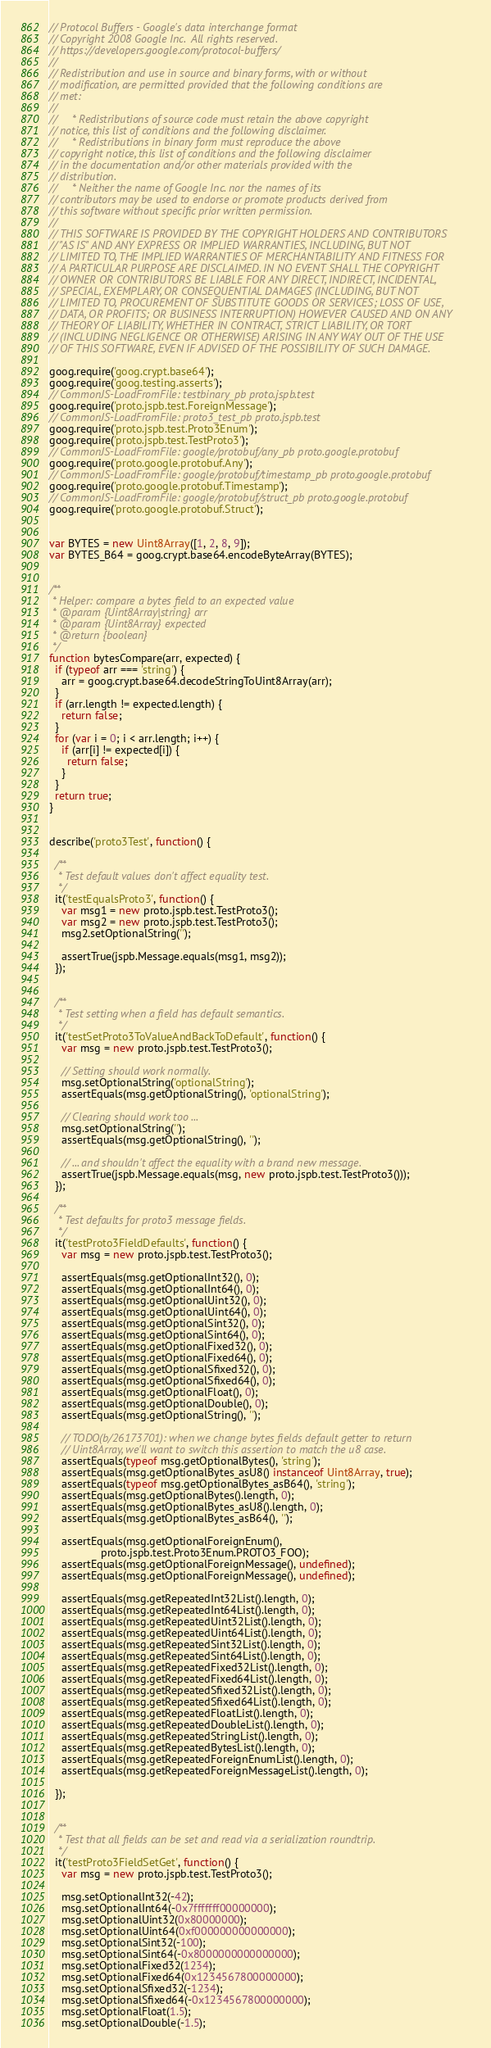Convert code to text. <code><loc_0><loc_0><loc_500><loc_500><_JavaScript_>// Protocol Buffers - Google's data interchange format
// Copyright 2008 Google Inc.  All rights reserved.
// https://developers.google.com/protocol-buffers/
//
// Redistribution and use in source and binary forms, with or without
// modification, are permitted provided that the following conditions are
// met:
//
//     * Redistributions of source code must retain the above copyright
// notice, this list of conditions and the following disclaimer.
//     * Redistributions in binary form must reproduce the above
// copyright notice, this list of conditions and the following disclaimer
// in the documentation and/or other materials provided with the
// distribution.
//     * Neither the name of Google Inc. nor the names of its
// contributors may be used to endorse or promote products derived from
// this software without specific prior written permission.
//
// THIS SOFTWARE IS PROVIDED BY THE COPYRIGHT HOLDERS AND CONTRIBUTORS
// "AS IS" AND ANY EXPRESS OR IMPLIED WARRANTIES, INCLUDING, BUT NOT
// LIMITED TO, THE IMPLIED WARRANTIES OF MERCHANTABILITY AND FITNESS FOR
// A PARTICULAR PURPOSE ARE DISCLAIMED. IN NO EVENT SHALL THE COPYRIGHT
// OWNER OR CONTRIBUTORS BE LIABLE FOR ANY DIRECT, INDIRECT, INCIDENTAL,
// SPECIAL, EXEMPLARY, OR CONSEQUENTIAL DAMAGES (INCLUDING, BUT NOT
// LIMITED TO, PROCUREMENT OF SUBSTITUTE GOODS OR SERVICES; LOSS OF USE,
// DATA, OR PROFITS; OR BUSINESS INTERRUPTION) HOWEVER CAUSED AND ON ANY
// THEORY OF LIABILITY, WHETHER IN CONTRACT, STRICT LIABILITY, OR TORT
// (INCLUDING NEGLIGENCE OR OTHERWISE) ARISING IN ANY WAY OUT OF THE USE
// OF THIS SOFTWARE, EVEN IF ADVISED OF THE POSSIBILITY OF SUCH DAMAGE.

goog.require('goog.crypt.base64');
goog.require('goog.testing.asserts');
// CommonJS-LoadFromFile: testbinary_pb proto.jspb.test
goog.require('proto.jspb.test.ForeignMessage');
// CommonJS-LoadFromFile: proto3_test_pb proto.jspb.test
goog.require('proto.jspb.test.Proto3Enum');
goog.require('proto.jspb.test.TestProto3');
// CommonJS-LoadFromFile: google/protobuf/any_pb proto.google.protobuf
goog.require('proto.google.protobuf.Any');
// CommonJS-LoadFromFile: google/protobuf/timestamp_pb proto.google.protobuf
goog.require('proto.google.protobuf.Timestamp');
// CommonJS-LoadFromFile: google/protobuf/struct_pb proto.google.protobuf
goog.require('proto.google.protobuf.Struct');


var BYTES = new Uint8Array([1, 2, 8, 9]);
var BYTES_B64 = goog.crypt.base64.encodeByteArray(BYTES);


/**
 * Helper: compare a bytes field to an expected value
 * @param {Uint8Array|string} arr
 * @param {Uint8Array} expected
 * @return {boolean}
 */
function bytesCompare(arr, expected) {
  if (typeof arr === 'string') {
    arr = goog.crypt.base64.decodeStringToUint8Array(arr);
  }
  if (arr.length != expected.length) {
    return false;
  }
  for (var i = 0; i < arr.length; i++) {
    if (arr[i] != expected[i]) {
      return false;
    }
  }
  return true;
}


describe('proto3Test', function() {

  /**
   * Test default values don't affect equality test.
   */
  it('testEqualsProto3', function() {
    var msg1 = new proto.jspb.test.TestProto3();
    var msg2 = new proto.jspb.test.TestProto3();
    msg2.setOptionalString('');

    assertTrue(jspb.Message.equals(msg1, msg2));
  });


  /**
   * Test setting when a field has default semantics.
   */
  it('testSetProto3ToValueAndBackToDefault', function() {
    var msg = new proto.jspb.test.TestProto3();

    // Setting should work normally.
    msg.setOptionalString('optionalString');
    assertEquals(msg.getOptionalString(), 'optionalString');

    // Clearing should work too ...
    msg.setOptionalString('');
    assertEquals(msg.getOptionalString(), '');

    // ... and shouldn't affect the equality with a brand new message.
    assertTrue(jspb.Message.equals(msg, new proto.jspb.test.TestProto3()));
  });

  /**
   * Test defaults for proto3 message fields.
   */
  it('testProto3FieldDefaults', function() {
    var msg = new proto.jspb.test.TestProto3();

    assertEquals(msg.getOptionalInt32(), 0);
    assertEquals(msg.getOptionalInt64(), 0);
    assertEquals(msg.getOptionalUint32(), 0);
    assertEquals(msg.getOptionalUint64(), 0);
    assertEquals(msg.getOptionalSint32(), 0);
    assertEquals(msg.getOptionalSint64(), 0);
    assertEquals(msg.getOptionalFixed32(), 0);
    assertEquals(msg.getOptionalFixed64(), 0);
    assertEquals(msg.getOptionalSfixed32(), 0);
    assertEquals(msg.getOptionalSfixed64(), 0);
    assertEquals(msg.getOptionalFloat(), 0);
    assertEquals(msg.getOptionalDouble(), 0);
    assertEquals(msg.getOptionalString(), '');

    // TODO(b/26173701): when we change bytes fields default getter to return
    // Uint8Array, we'll want to switch this assertion to match the u8 case.
    assertEquals(typeof msg.getOptionalBytes(), 'string');
    assertEquals(msg.getOptionalBytes_asU8() instanceof Uint8Array, true);
    assertEquals(typeof msg.getOptionalBytes_asB64(), 'string');
    assertEquals(msg.getOptionalBytes().length, 0);
    assertEquals(msg.getOptionalBytes_asU8().length, 0);
    assertEquals(msg.getOptionalBytes_asB64(), '');

    assertEquals(msg.getOptionalForeignEnum(),
                 proto.jspb.test.Proto3Enum.PROTO3_FOO);
    assertEquals(msg.getOptionalForeignMessage(), undefined);
    assertEquals(msg.getOptionalForeignMessage(), undefined);

    assertEquals(msg.getRepeatedInt32List().length, 0);
    assertEquals(msg.getRepeatedInt64List().length, 0);
    assertEquals(msg.getRepeatedUint32List().length, 0);
    assertEquals(msg.getRepeatedUint64List().length, 0);
    assertEquals(msg.getRepeatedSint32List().length, 0);
    assertEquals(msg.getRepeatedSint64List().length, 0);
    assertEquals(msg.getRepeatedFixed32List().length, 0);
    assertEquals(msg.getRepeatedFixed64List().length, 0);
    assertEquals(msg.getRepeatedSfixed32List().length, 0);
    assertEquals(msg.getRepeatedSfixed64List().length, 0);
    assertEquals(msg.getRepeatedFloatList().length, 0);
    assertEquals(msg.getRepeatedDoubleList().length, 0);
    assertEquals(msg.getRepeatedStringList().length, 0);
    assertEquals(msg.getRepeatedBytesList().length, 0);
    assertEquals(msg.getRepeatedForeignEnumList().length, 0);
    assertEquals(msg.getRepeatedForeignMessageList().length, 0);

  });


  /**
   * Test that all fields can be set and read via a serialization roundtrip.
   */
  it('testProto3FieldSetGet', function() {
    var msg = new proto.jspb.test.TestProto3();

    msg.setOptionalInt32(-42);
    msg.setOptionalInt64(-0x7fffffff00000000);
    msg.setOptionalUint32(0x80000000);
    msg.setOptionalUint64(0xf000000000000000);
    msg.setOptionalSint32(-100);
    msg.setOptionalSint64(-0x8000000000000000);
    msg.setOptionalFixed32(1234);
    msg.setOptionalFixed64(0x1234567800000000);
    msg.setOptionalSfixed32(-1234);
    msg.setOptionalSfixed64(-0x1234567800000000);
    msg.setOptionalFloat(1.5);
    msg.setOptionalDouble(-1.5);</code> 